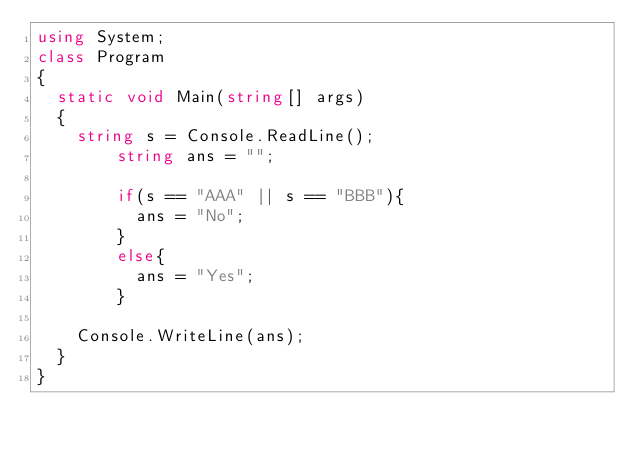<code> <loc_0><loc_0><loc_500><loc_500><_C#_>using System;
class Program
{
	static void Main(string[] args)
	{
		string s = Console.ReadLine();	
      	string ans = "";
      	
      	if(s == "AAA" || s == "BBB"){
          ans = "No";
        }
      	else{
          ans = "Yes";
        }
      	
		Console.WriteLine(ans);
	}
}</code> 